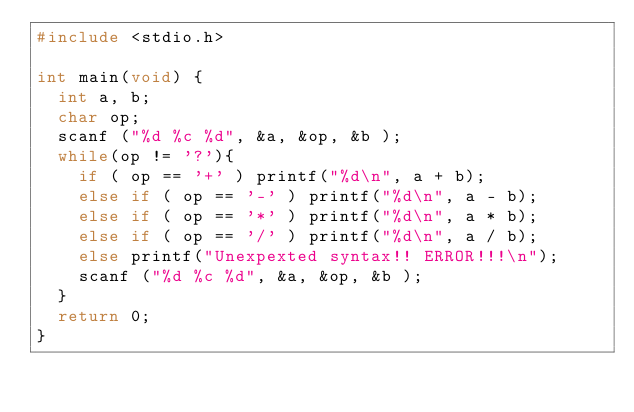Convert code to text. <code><loc_0><loc_0><loc_500><loc_500><_C_>#include <stdio.h>

int main(void) {
  int a, b;
  char op;
  scanf ("%d %c %d", &a, &op, &b );
  while(op != '?'){
    if ( op == '+' ) printf("%d\n", a + b);
    else if ( op == '-' ) printf("%d\n", a - b);
    else if ( op == '*' ) printf("%d\n", a * b);
    else if ( op == '/' ) printf("%d\n", a / b);
    else printf("Unexpexted syntax!! ERROR!!!\n");
    scanf ("%d %c %d", &a, &op, &b );
  }
  return 0;
}

</code> 